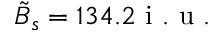<formula> <loc_0><loc_0><loc_500><loc_500>\tilde { B } _ { s } = 1 3 4 . 2 i . u .</formula> 